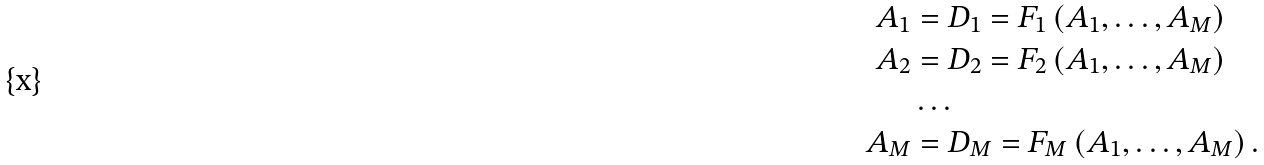Convert formula to latex. <formula><loc_0><loc_0><loc_500><loc_500>A _ { 1 } & = D _ { 1 } = F _ { 1 } \left ( A _ { 1 } , \dots , A _ { M } \right ) \\ A _ { 2 } & = D _ { 2 } = F _ { 2 } \left ( A _ { 1 } , \dots , A _ { M } \right ) \\ & \dots \\ A _ { M } & = D _ { M } = F _ { M } \left ( A _ { 1 } , \dots , A _ { M } \right ) .</formula> 